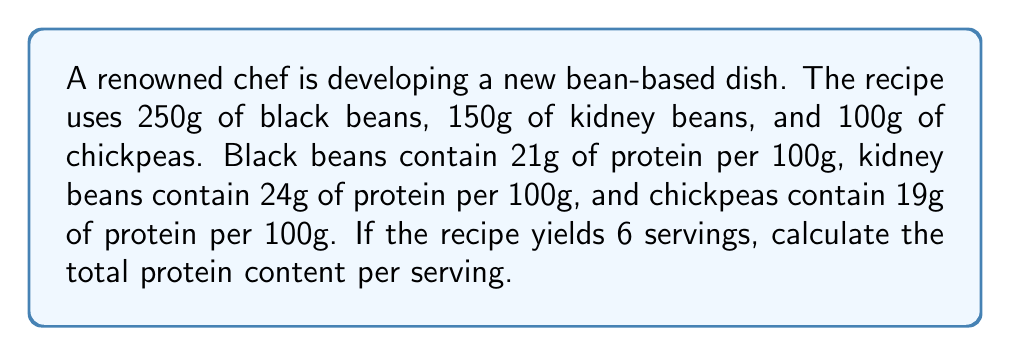Provide a solution to this math problem. Let's approach this step-by-step:

1) First, calculate the protein content for each type of bean:

   Black beans: $\frac{250g}{100g} \times 21g = 52.5g$ protein
   Kidney beans: $\frac{150g}{100g} \times 24g = 36g$ protein
   Chickpeas: $\frac{100g}{100g} \times 19g = 19g$ protein

2) Now, sum up the total protein content:

   Total protein = $52.5g + 36g + 19g = 107.5g$

3) The recipe yields 6 servings, so divide the total protein by 6:

   Protein per serving = $\frac{107.5g}{6} = 17.92g$

Therefore, each serving contains approximately 17.92g of protein.
Answer: $17.92g$ 